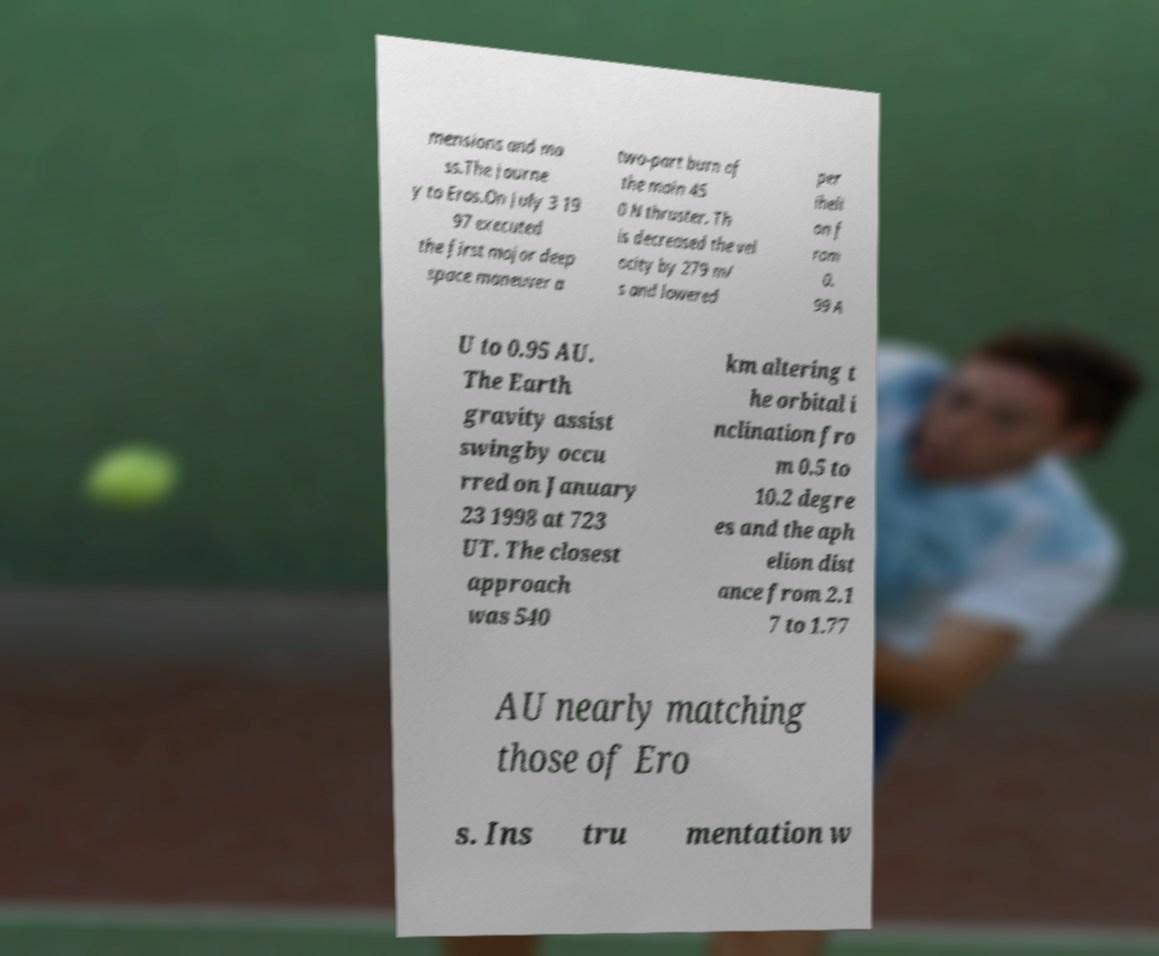Can you accurately transcribe the text from the provided image for me? mensions and ma ss.The journe y to Eros.On July 3 19 97 executed the first major deep space maneuver a two-part burn of the main 45 0 N thruster. Th is decreased the vel ocity by 279 m/ s and lowered per iheli on f rom 0. 99 A U to 0.95 AU. The Earth gravity assist swingby occu rred on January 23 1998 at 723 UT. The closest approach was 540 km altering t he orbital i nclination fro m 0.5 to 10.2 degre es and the aph elion dist ance from 2.1 7 to 1.77 AU nearly matching those of Ero s. Ins tru mentation w 